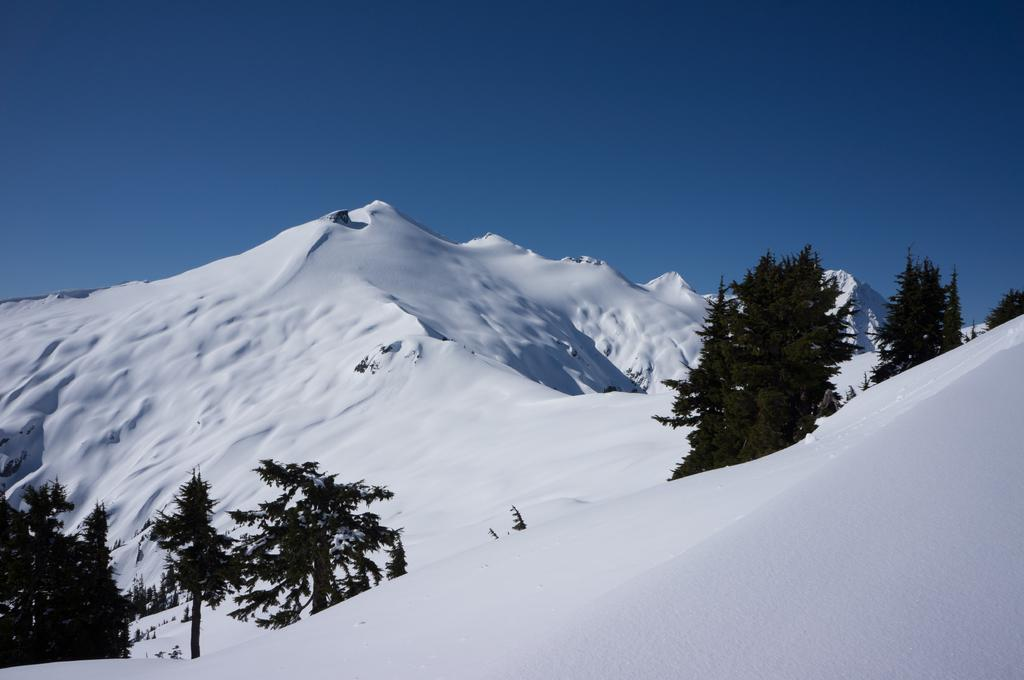What type of vegetation can be seen in the image? There are trees in the image. What is the color of the trees? The trees are green in color. What can be seen in the background of the image? There is snow and the sky visible in the background of the image. What is the color of the snow? The snow is white in color. What is the color of the sky in the image? The sky is blue in color. What type of finger can be seen holding the title in the image? There is no finger or title present in the image; it features trees, snow, and a blue sky. 